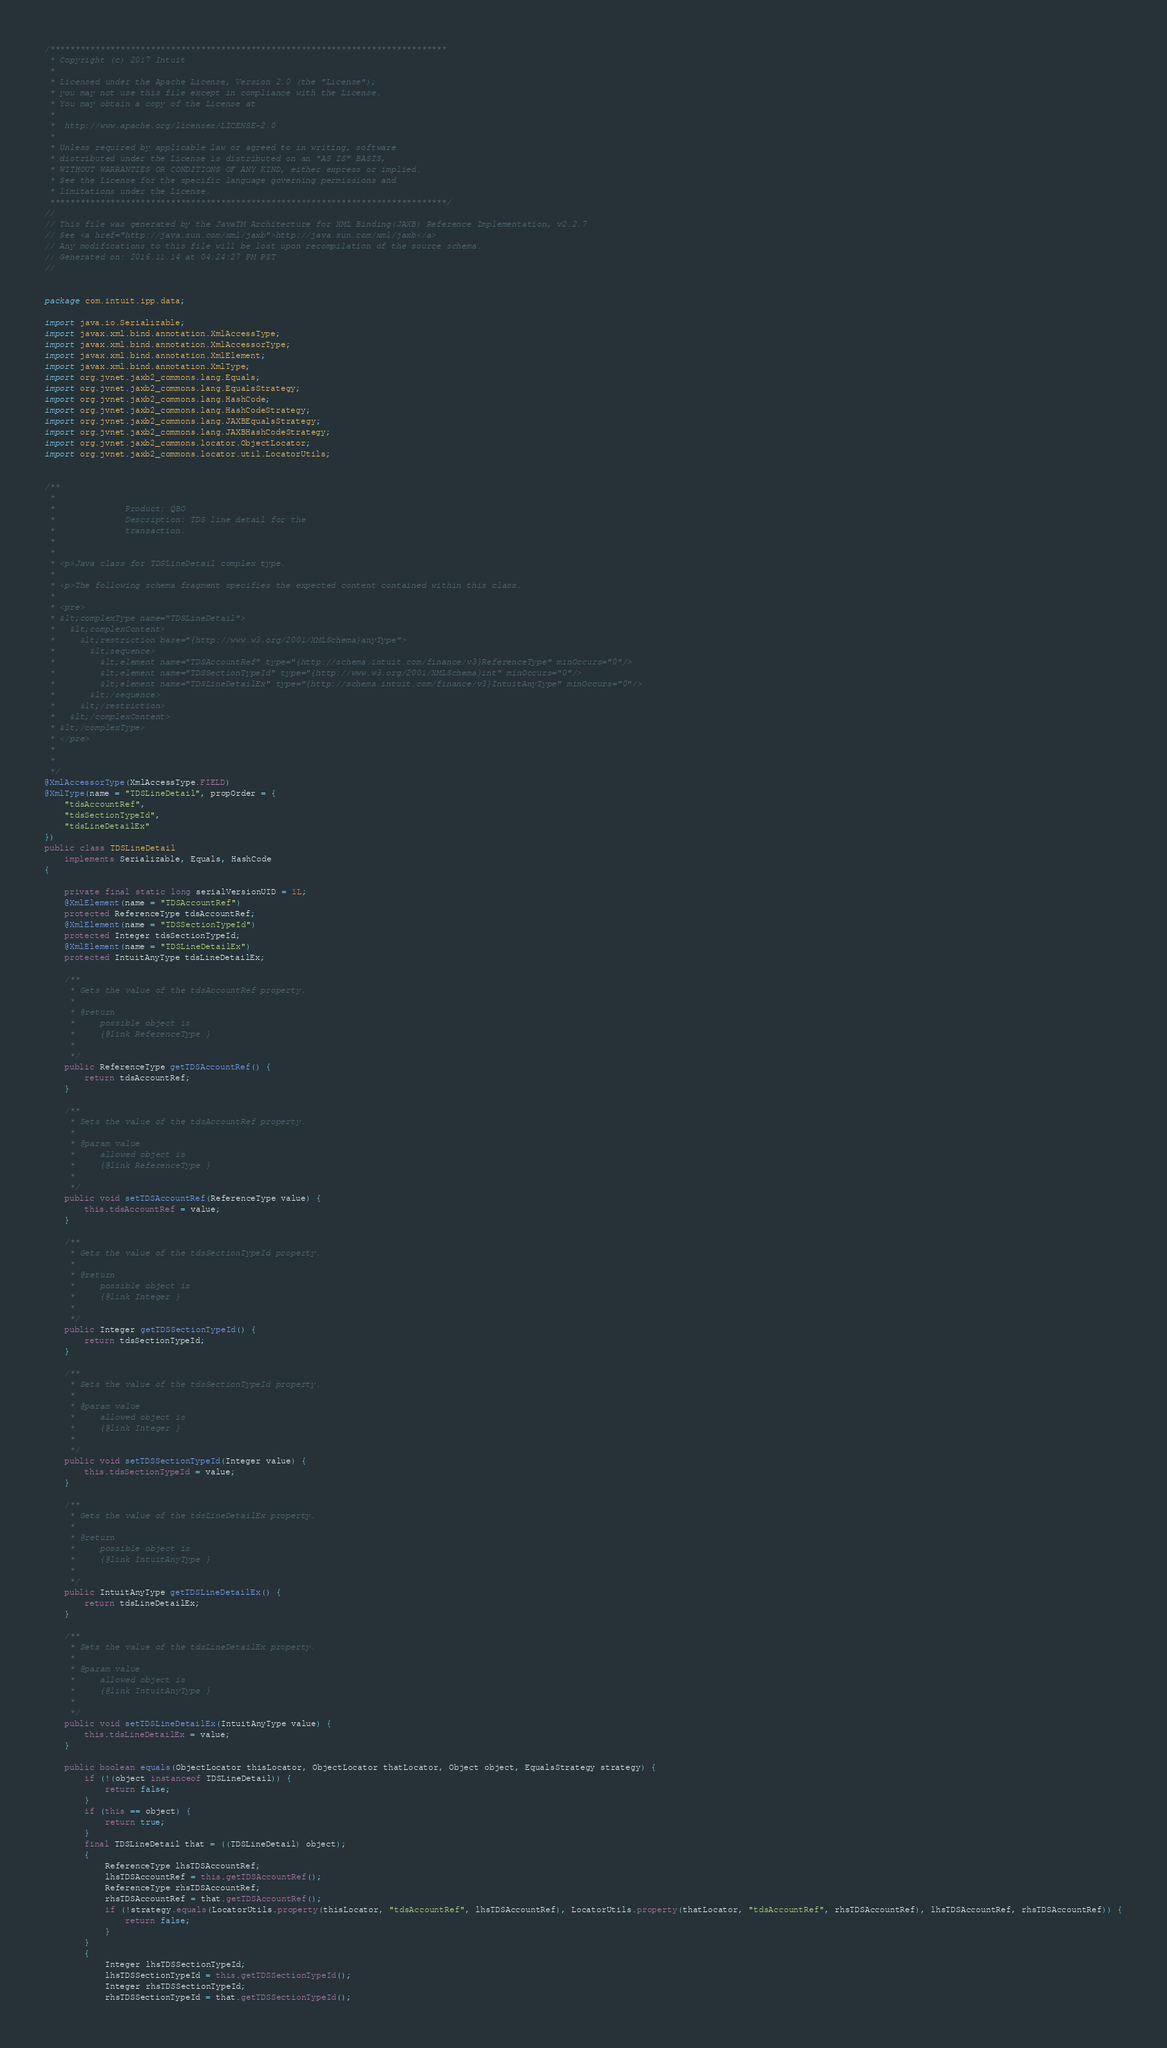<code> <loc_0><loc_0><loc_500><loc_500><_Java_>/*******************************************************************************
 * Copyright (c) 2017 Intuit
 *
 * Licensed under the Apache License, Version 2.0 (the "License");
 * you may not use this file except in compliance with the License.
 * You may obtain a copy of the License at
 *
 * 	http://www.apache.org/licenses/LICENSE-2.0
 *
 * Unless required by applicable law or agreed to in writing, software
 * distributed under the License is distributed on an "AS IS" BASIS,
 * WITHOUT WARRANTIES OR CONDITIONS OF ANY KIND, either express or implied.
 * See the License for the specific language governing permissions and
 * limitations under the License.
 *******************************************************************************/
//
// This file was generated by the JavaTM Architecture for XML Binding(JAXB) Reference Implementation, v2.2.7 
// See <a href="http://java.sun.com/xml/jaxb">http://java.sun.com/xml/jaxb</a> 
// Any modifications to this file will be lost upon recompilation of the source schema. 
// Generated on: 2016.11.14 at 04:24:27 PM PST 
//


package com.intuit.ipp.data;

import java.io.Serializable;
import javax.xml.bind.annotation.XmlAccessType;
import javax.xml.bind.annotation.XmlAccessorType;
import javax.xml.bind.annotation.XmlElement;
import javax.xml.bind.annotation.XmlType;
import org.jvnet.jaxb2_commons.lang.Equals;
import org.jvnet.jaxb2_commons.lang.EqualsStrategy;
import org.jvnet.jaxb2_commons.lang.HashCode;
import org.jvnet.jaxb2_commons.lang.HashCodeStrategy;
import org.jvnet.jaxb2_commons.lang.JAXBEqualsStrategy;
import org.jvnet.jaxb2_commons.lang.JAXBHashCodeStrategy;
import org.jvnet.jaxb2_commons.locator.ObjectLocator;
import org.jvnet.jaxb2_commons.locator.util.LocatorUtils;


/**
 * 
 * 				Product: QBO
 * 				Description: TDS line detail for the
 * 				transaction.
 * 			
 * 
 * <p>Java class for TDSLineDetail complex type.
 * 
 * <p>The following schema fragment specifies the expected content contained within this class.
 * 
 * <pre>
 * &lt;complexType name="TDSLineDetail">
 *   &lt;complexContent>
 *     &lt;restriction base="{http://www.w3.org/2001/XMLSchema}anyType">
 *       &lt;sequence>
 *         &lt;element name="TDSAccountRef" type="{http://schema.intuit.com/finance/v3}ReferenceType" minOccurs="0"/>
 *         &lt;element name="TDSSectionTypeId" type="{http://www.w3.org/2001/XMLSchema}int" minOccurs="0"/>
 *         &lt;element name="TDSLineDetailEx" type="{http://schema.intuit.com/finance/v3}IntuitAnyType" minOccurs="0"/>
 *       &lt;/sequence>
 *     &lt;/restriction>
 *   &lt;/complexContent>
 * &lt;/complexType>
 * </pre>
 * 
 * 
 */
@XmlAccessorType(XmlAccessType.FIELD)
@XmlType(name = "TDSLineDetail", propOrder = {
    "tdsAccountRef",
    "tdsSectionTypeId",
    "tdsLineDetailEx"
})
public class TDSLineDetail
    implements Serializable, Equals, HashCode
{

    private final static long serialVersionUID = 1L;
    @XmlElement(name = "TDSAccountRef")
    protected ReferenceType tdsAccountRef;
    @XmlElement(name = "TDSSectionTypeId")
    protected Integer tdsSectionTypeId;
    @XmlElement(name = "TDSLineDetailEx")
    protected IntuitAnyType tdsLineDetailEx;

    /**
     * Gets the value of the tdsAccountRef property.
     * 
     * @return
     *     possible object is
     *     {@link ReferenceType }
     *     
     */
    public ReferenceType getTDSAccountRef() {
        return tdsAccountRef;
    }

    /**
     * Sets the value of the tdsAccountRef property.
     * 
     * @param value
     *     allowed object is
     *     {@link ReferenceType }
     *     
     */
    public void setTDSAccountRef(ReferenceType value) {
        this.tdsAccountRef = value;
    }

    /**
     * Gets the value of the tdsSectionTypeId property.
     * 
     * @return
     *     possible object is
     *     {@link Integer }
     *     
     */
    public Integer getTDSSectionTypeId() {
        return tdsSectionTypeId;
    }

    /**
     * Sets the value of the tdsSectionTypeId property.
     * 
     * @param value
     *     allowed object is
     *     {@link Integer }
     *     
     */
    public void setTDSSectionTypeId(Integer value) {
        this.tdsSectionTypeId = value;
    }

    /**
     * Gets the value of the tdsLineDetailEx property.
     * 
     * @return
     *     possible object is
     *     {@link IntuitAnyType }
     *     
     */
    public IntuitAnyType getTDSLineDetailEx() {
        return tdsLineDetailEx;
    }

    /**
     * Sets the value of the tdsLineDetailEx property.
     * 
     * @param value
     *     allowed object is
     *     {@link IntuitAnyType }
     *     
     */
    public void setTDSLineDetailEx(IntuitAnyType value) {
        this.tdsLineDetailEx = value;
    }

    public boolean equals(ObjectLocator thisLocator, ObjectLocator thatLocator, Object object, EqualsStrategy strategy) {
        if (!(object instanceof TDSLineDetail)) {
            return false;
        }
        if (this == object) {
            return true;
        }
        final TDSLineDetail that = ((TDSLineDetail) object);
        {
            ReferenceType lhsTDSAccountRef;
            lhsTDSAccountRef = this.getTDSAccountRef();
            ReferenceType rhsTDSAccountRef;
            rhsTDSAccountRef = that.getTDSAccountRef();
            if (!strategy.equals(LocatorUtils.property(thisLocator, "tdsAccountRef", lhsTDSAccountRef), LocatorUtils.property(thatLocator, "tdsAccountRef", rhsTDSAccountRef), lhsTDSAccountRef, rhsTDSAccountRef)) {
                return false;
            }
        }
        {
            Integer lhsTDSSectionTypeId;
            lhsTDSSectionTypeId = this.getTDSSectionTypeId();
            Integer rhsTDSSectionTypeId;
            rhsTDSSectionTypeId = that.getTDSSectionTypeId();</code> 